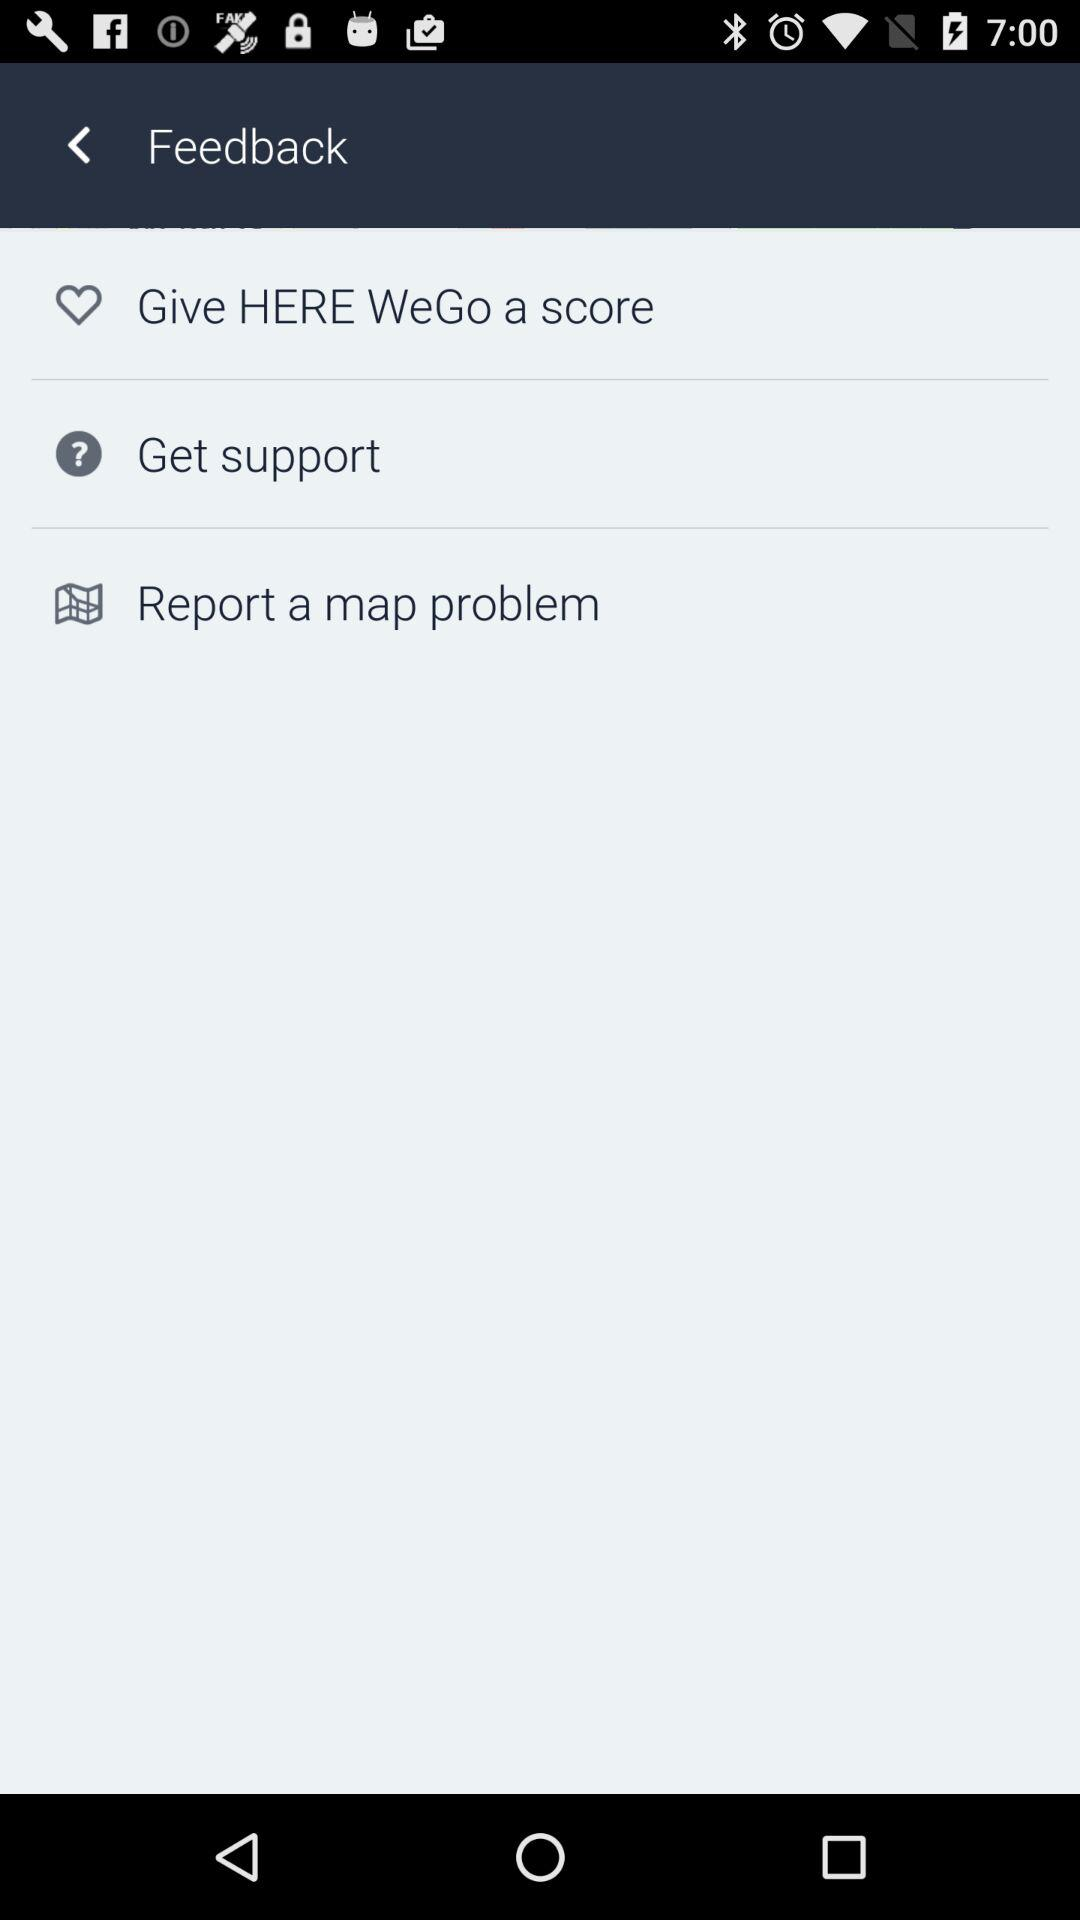How many feedback options are there?
Answer the question using a single word or phrase. 3 